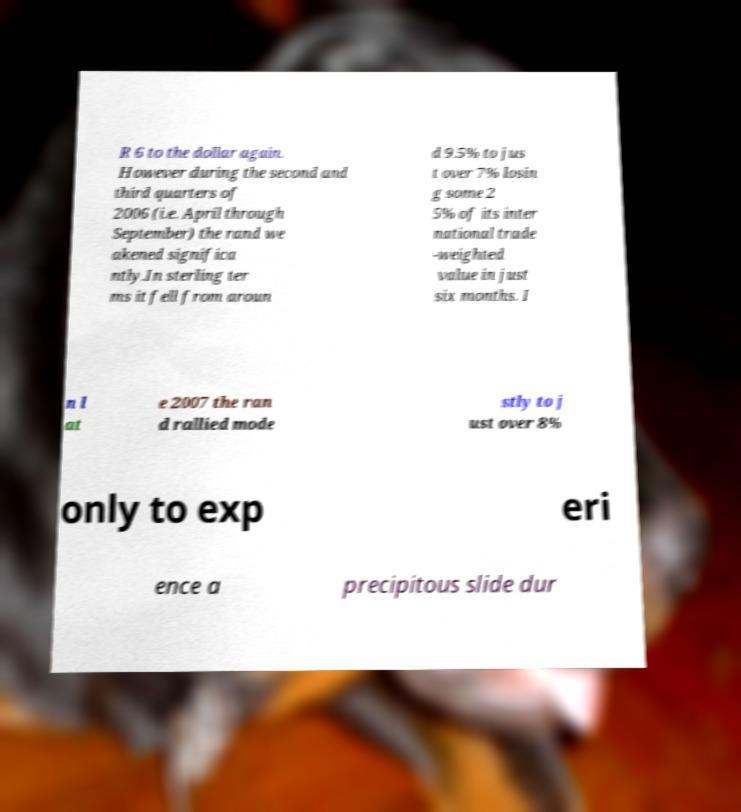Can you accurately transcribe the text from the provided image for me? R 6 to the dollar again. However during the second and third quarters of 2006 (i.e. April through September) the rand we akened significa ntly.In sterling ter ms it fell from aroun d 9.5% to jus t over 7% losin g some 2 5% of its inter national trade -weighted value in just six months. I n l at e 2007 the ran d rallied mode stly to j ust over 8% only to exp eri ence a precipitous slide dur 